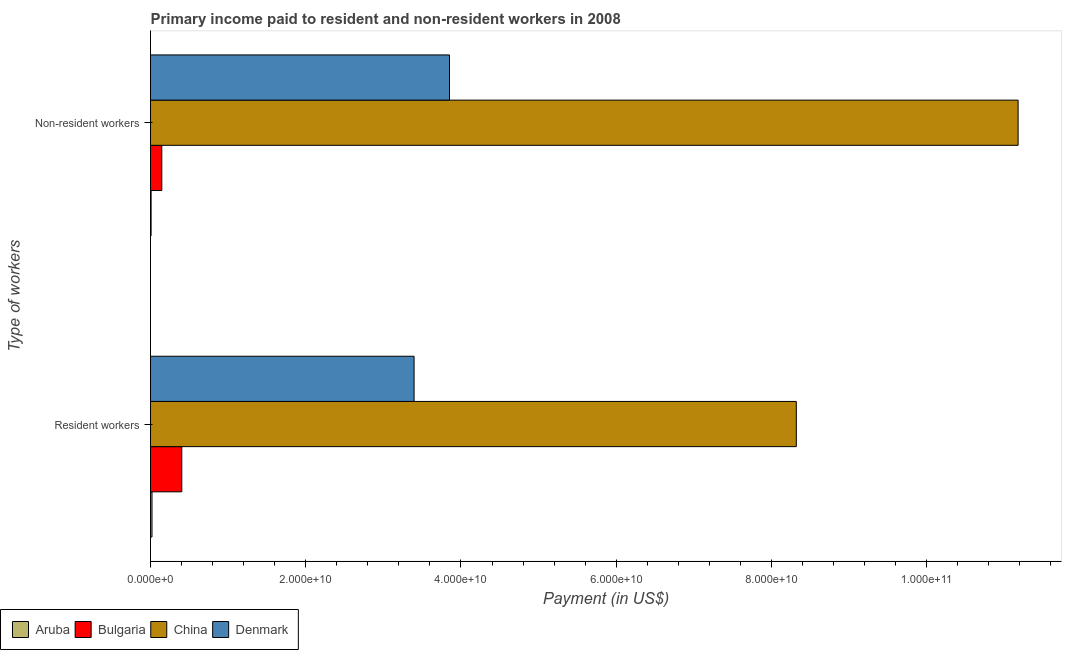How many groups of bars are there?
Offer a terse response. 2. Are the number of bars per tick equal to the number of legend labels?
Provide a short and direct response. Yes. How many bars are there on the 2nd tick from the bottom?
Provide a succinct answer. 4. What is the label of the 2nd group of bars from the top?
Ensure brevity in your answer.  Resident workers. What is the payment made to resident workers in Denmark?
Your answer should be very brief. 3.40e+1. Across all countries, what is the maximum payment made to non-resident workers?
Give a very brief answer. 1.12e+11. Across all countries, what is the minimum payment made to resident workers?
Give a very brief answer. 1.89e+08. In which country was the payment made to resident workers minimum?
Offer a terse response. Aruba. What is the total payment made to resident workers in the graph?
Your answer should be very brief. 1.21e+11. What is the difference between the payment made to resident workers in Denmark and that in China?
Provide a succinct answer. -4.92e+1. What is the difference between the payment made to non-resident workers in Aruba and the payment made to resident workers in China?
Your answer should be very brief. -8.31e+1. What is the average payment made to non-resident workers per country?
Offer a very short reply. 3.80e+1. What is the difference between the payment made to non-resident workers and payment made to resident workers in Bulgaria?
Your answer should be compact. -2.58e+09. What is the ratio of the payment made to resident workers in Denmark to that in Bulgaria?
Keep it short and to the point. 8.43. Is the payment made to non-resident workers in China less than that in Denmark?
Ensure brevity in your answer.  No. In how many countries, is the payment made to non-resident workers greater than the average payment made to non-resident workers taken over all countries?
Your response must be concise. 2. How many bars are there?
Ensure brevity in your answer.  8. How many countries are there in the graph?
Your response must be concise. 4. Are the values on the major ticks of X-axis written in scientific E-notation?
Offer a terse response. Yes. Does the graph contain any zero values?
Your answer should be very brief. No. Does the graph contain grids?
Provide a short and direct response. No. Where does the legend appear in the graph?
Your answer should be very brief. Bottom left. How many legend labels are there?
Give a very brief answer. 4. How are the legend labels stacked?
Make the answer very short. Horizontal. What is the title of the graph?
Offer a terse response. Primary income paid to resident and non-resident workers in 2008. Does "Low income" appear as one of the legend labels in the graph?
Make the answer very short. No. What is the label or title of the X-axis?
Your answer should be very brief. Payment (in US$). What is the label or title of the Y-axis?
Keep it short and to the point. Type of workers. What is the Payment (in US$) in Aruba in Resident workers?
Your answer should be compact. 1.89e+08. What is the Payment (in US$) in Bulgaria in Resident workers?
Provide a short and direct response. 4.03e+09. What is the Payment (in US$) of China in Resident workers?
Ensure brevity in your answer.  8.32e+1. What is the Payment (in US$) of Denmark in Resident workers?
Provide a short and direct response. 3.40e+1. What is the Payment (in US$) of Aruba in Non-resident workers?
Your answer should be very brief. 7.18e+07. What is the Payment (in US$) in Bulgaria in Non-resident workers?
Your answer should be very brief. 1.45e+09. What is the Payment (in US$) of China in Non-resident workers?
Provide a succinct answer. 1.12e+11. What is the Payment (in US$) of Denmark in Non-resident workers?
Give a very brief answer. 3.85e+1. Across all Type of workers, what is the maximum Payment (in US$) in Aruba?
Make the answer very short. 1.89e+08. Across all Type of workers, what is the maximum Payment (in US$) of Bulgaria?
Your response must be concise. 4.03e+09. Across all Type of workers, what is the maximum Payment (in US$) of China?
Your answer should be very brief. 1.12e+11. Across all Type of workers, what is the maximum Payment (in US$) in Denmark?
Ensure brevity in your answer.  3.85e+1. Across all Type of workers, what is the minimum Payment (in US$) in Aruba?
Your response must be concise. 7.18e+07. Across all Type of workers, what is the minimum Payment (in US$) in Bulgaria?
Offer a very short reply. 1.45e+09. Across all Type of workers, what is the minimum Payment (in US$) of China?
Keep it short and to the point. 8.32e+1. Across all Type of workers, what is the minimum Payment (in US$) in Denmark?
Give a very brief answer. 3.40e+1. What is the total Payment (in US$) in Aruba in the graph?
Offer a terse response. 2.60e+08. What is the total Payment (in US$) of Bulgaria in the graph?
Your answer should be compact. 5.48e+09. What is the total Payment (in US$) in China in the graph?
Give a very brief answer. 1.95e+11. What is the total Payment (in US$) of Denmark in the graph?
Offer a terse response. 7.25e+1. What is the difference between the Payment (in US$) in Aruba in Resident workers and that in Non-resident workers?
Your response must be concise. 1.17e+08. What is the difference between the Payment (in US$) of Bulgaria in Resident workers and that in Non-resident workers?
Offer a terse response. 2.58e+09. What is the difference between the Payment (in US$) of China in Resident workers and that in Non-resident workers?
Make the answer very short. -2.86e+1. What is the difference between the Payment (in US$) of Denmark in Resident workers and that in Non-resident workers?
Offer a terse response. -4.56e+09. What is the difference between the Payment (in US$) in Aruba in Resident workers and the Payment (in US$) in Bulgaria in Non-resident workers?
Offer a very short reply. -1.26e+09. What is the difference between the Payment (in US$) of Aruba in Resident workers and the Payment (in US$) of China in Non-resident workers?
Keep it short and to the point. -1.12e+11. What is the difference between the Payment (in US$) in Aruba in Resident workers and the Payment (in US$) in Denmark in Non-resident workers?
Give a very brief answer. -3.83e+1. What is the difference between the Payment (in US$) in Bulgaria in Resident workers and the Payment (in US$) in China in Non-resident workers?
Offer a very short reply. -1.08e+11. What is the difference between the Payment (in US$) of Bulgaria in Resident workers and the Payment (in US$) of Denmark in Non-resident workers?
Give a very brief answer. -3.45e+1. What is the difference between the Payment (in US$) in China in Resident workers and the Payment (in US$) in Denmark in Non-resident workers?
Give a very brief answer. 4.47e+1. What is the average Payment (in US$) of Aruba per Type of workers?
Your response must be concise. 1.30e+08. What is the average Payment (in US$) in Bulgaria per Type of workers?
Ensure brevity in your answer.  2.74e+09. What is the average Payment (in US$) in China per Type of workers?
Make the answer very short. 9.75e+1. What is the average Payment (in US$) of Denmark per Type of workers?
Your answer should be compact. 3.62e+1. What is the difference between the Payment (in US$) in Aruba and Payment (in US$) in Bulgaria in Resident workers?
Offer a very short reply. -3.84e+09. What is the difference between the Payment (in US$) in Aruba and Payment (in US$) in China in Resident workers?
Your response must be concise. -8.30e+1. What is the difference between the Payment (in US$) of Aruba and Payment (in US$) of Denmark in Resident workers?
Provide a succinct answer. -3.38e+1. What is the difference between the Payment (in US$) of Bulgaria and Payment (in US$) of China in Resident workers?
Ensure brevity in your answer.  -7.92e+1. What is the difference between the Payment (in US$) in Bulgaria and Payment (in US$) in Denmark in Resident workers?
Your answer should be compact. -2.99e+1. What is the difference between the Payment (in US$) in China and Payment (in US$) in Denmark in Resident workers?
Offer a terse response. 4.92e+1. What is the difference between the Payment (in US$) of Aruba and Payment (in US$) of Bulgaria in Non-resident workers?
Keep it short and to the point. -1.38e+09. What is the difference between the Payment (in US$) in Aruba and Payment (in US$) in China in Non-resident workers?
Ensure brevity in your answer.  -1.12e+11. What is the difference between the Payment (in US$) of Aruba and Payment (in US$) of Denmark in Non-resident workers?
Give a very brief answer. -3.85e+1. What is the difference between the Payment (in US$) of Bulgaria and Payment (in US$) of China in Non-resident workers?
Your answer should be very brief. -1.10e+11. What is the difference between the Payment (in US$) in Bulgaria and Payment (in US$) in Denmark in Non-resident workers?
Your answer should be very brief. -3.71e+1. What is the difference between the Payment (in US$) of China and Payment (in US$) of Denmark in Non-resident workers?
Your answer should be compact. 7.33e+1. What is the ratio of the Payment (in US$) in Aruba in Resident workers to that in Non-resident workers?
Your answer should be compact. 2.63. What is the ratio of the Payment (in US$) in Bulgaria in Resident workers to that in Non-resident workers?
Your answer should be compact. 2.78. What is the ratio of the Payment (in US$) in China in Resident workers to that in Non-resident workers?
Keep it short and to the point. 0.74. What is the ratio of the Payment (in US$) of Denmark in Resident workers to that in Non-resident workers?
Ensure brevity in your answer.  0.88. What is the difference between the highest and the second highest Payment (in US$) in Aruba?
Your answer should be very brief. 1.17e+08. What is the difference between the highest and the second highest Payment (in US$) of Bulgaria?
Ensure brevity in your answer.  2.58e+09. What is the difference between the highest and the second highest Payment (in US$) in China?
Offer a terse response. 2.86e+1. What is the difference between the highest and the second highest Payment (in US$) of Denmark?
Your answer should be compact. 4.56e+09. What is the difference between the highest and the lowest Payment (in US$) in Aruba?
Offer a terse response. 1.17e+08. What is the difference between the highest and the lowest Payment (in US$) of Bulgaria?
Provide a succinct answer. 2.58e+09. What is the difference between the highest and the lowest Payment (in US$) of China?
Keep it short and to the point. 2.86e+1. What is the difference between the highest and the lowest Payment (in US$) in Denmark?
Keep it short and to the point. 4.56e+09. 